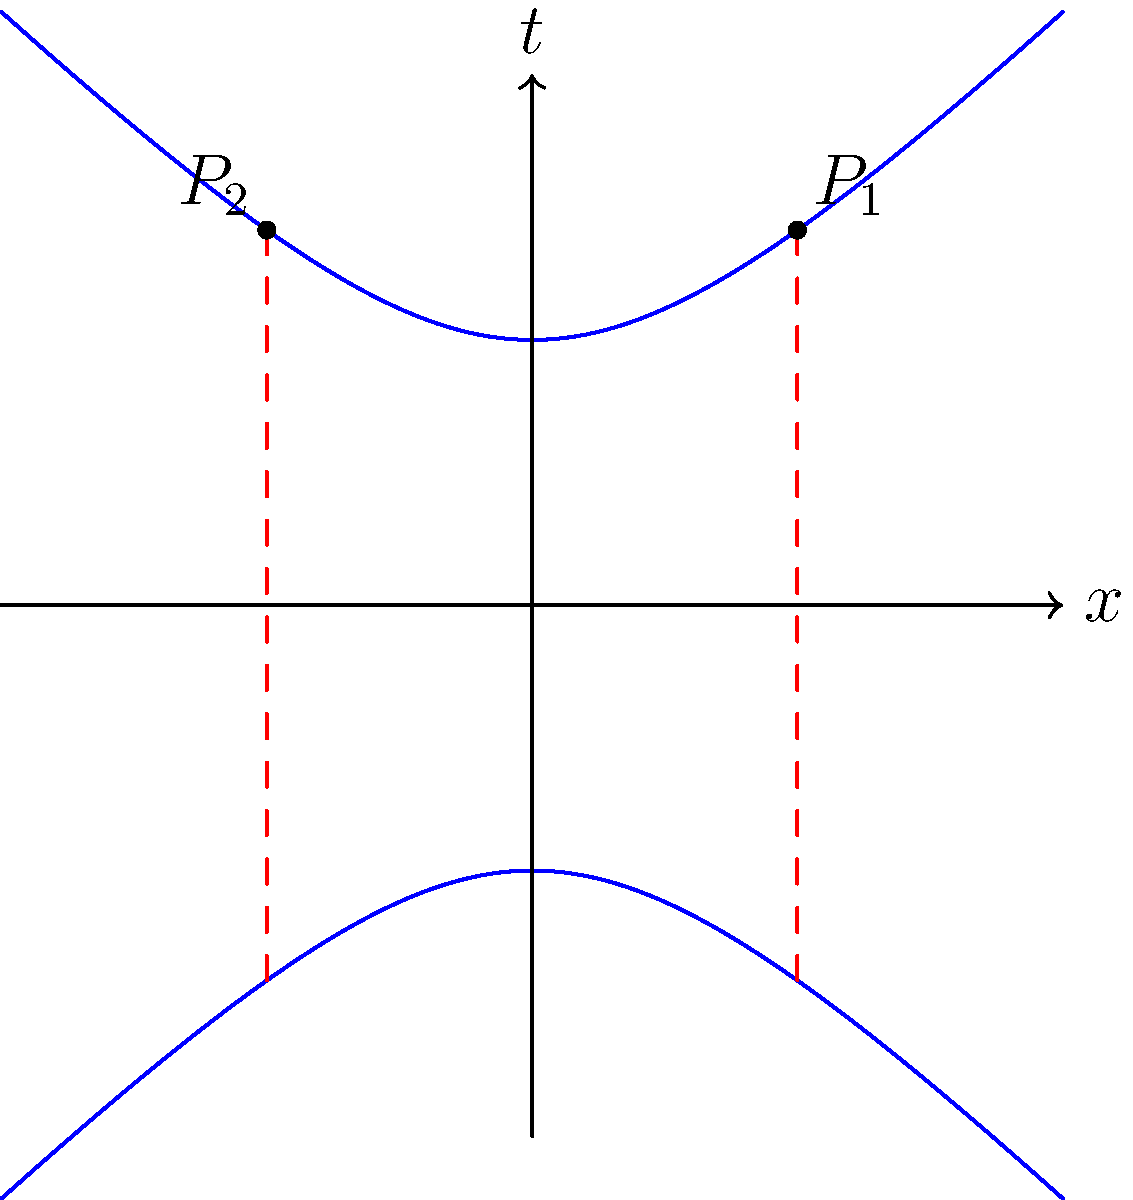In the context of high-performance computing for enterprise clients, how does the illustrated Non-Euclidean geometry of curved spacetime affect the implementation of parallel computing algorithms? Consider the two points $P_1$ and $P_2$ on the hyperbolic curve. To understand how Non-Euclidean geometry affects parallel computing in curved spacetime, let's break it down step-by-step:

1. The diagram illustrates a hyperbolic space, which is a type of Non-Euclidean geometry. The blue curves represent the hyperbola $t^2 - x^2 = 1$ in two-dimensional Minkowski spacetime.

2. In Euclidean space, parallel lines maintain a constant distance. However, in this hyperbolic space, the concept of "parallel" is different.

3. The red dashed lines through points $P_1$ and $P_2$ represent world lines of two hypothetical parallel processes in our computing system.

4. In curved spacetime:
   a) The distance between these world lines is not constant.
   b) The rate of time passage is not uniform across space.

5. For parallel computing, this implies:
   a) Synchronization becomes more complex: Processes that start simultaneously may not remain in sync due to time dilation effects.
   b) Data locality is affected: The concept of "nearby" data points becomes distorted, potentially impacting cache efficiency and data transfer times.
   c) Load balancing is challenging: Equal distribution of work across processors becomes non-trivial when space and time are warped.

6. In practice, for high-performance computing products:
   a) Algorithms need to be adapted to account for these geometric effects, especially for simulations involving relativistic physics or cosmology.
   b) Communication protocols between nodes must consider the potential for varying time rates and distances.
   c) Resource allocation and scheduling systems need to incorporate these geometric considerations for optimal performance.

7. For enterprise clients using such systems:
   a) Traditional benchmarks may not accurately reflect performance in Non-Euclidean scenarios.
   b) Software and hardware solutions need to be specifically designed or optimized for these geometric conditions.
   c) Training and documentation should include explanations of these concepts to ensure proper utilization of the computing resources.
Answer: Non-Euclidean geometry in curved spacetime complicates synchronization, data locality, and load balancing in parallel computing, requiring specialized algorithms and hardware optimizations for high-performance computing in relativistic or cosmological simulations. 